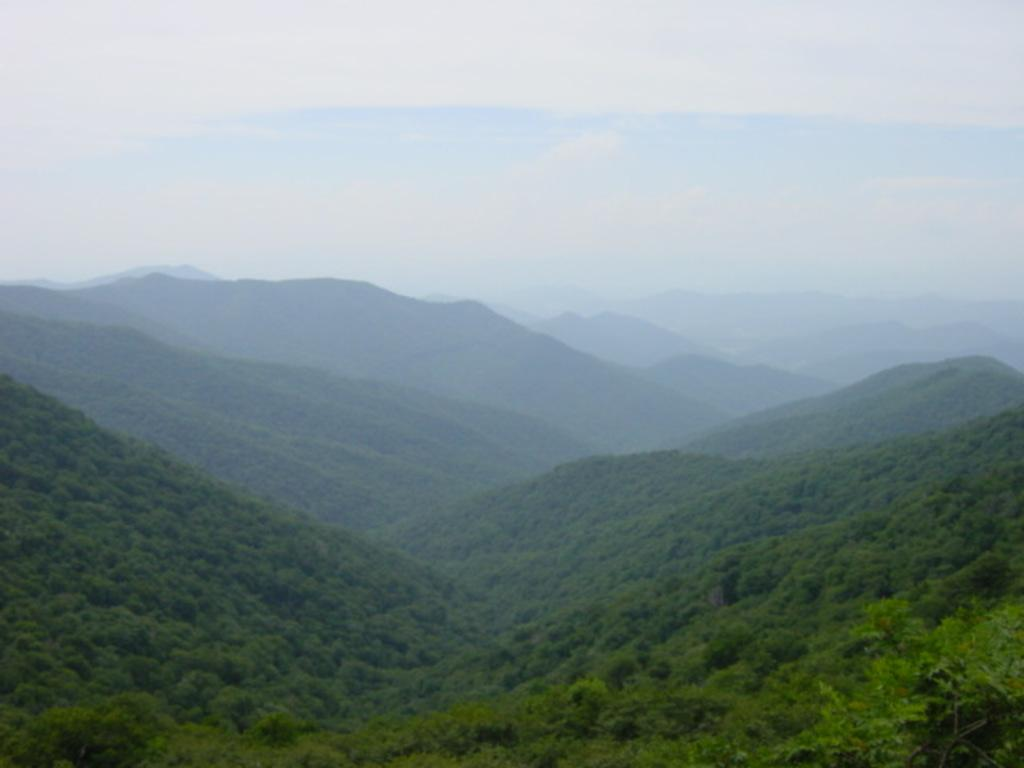What type of vegetation can be seen on the mountains in the image? There are trees on the mountains in the image. What can be seen in the sky in the image? There are clouds in the sky in the image. What color is the sky in the image? The sky is blue in the image. How many chickens are perched on the scarf in the image? There are no chickens or scarf present in the image. What color is the rub on the trees in the image? There is no rub on the trees in the image; the trees are simply visible on the mountains. 